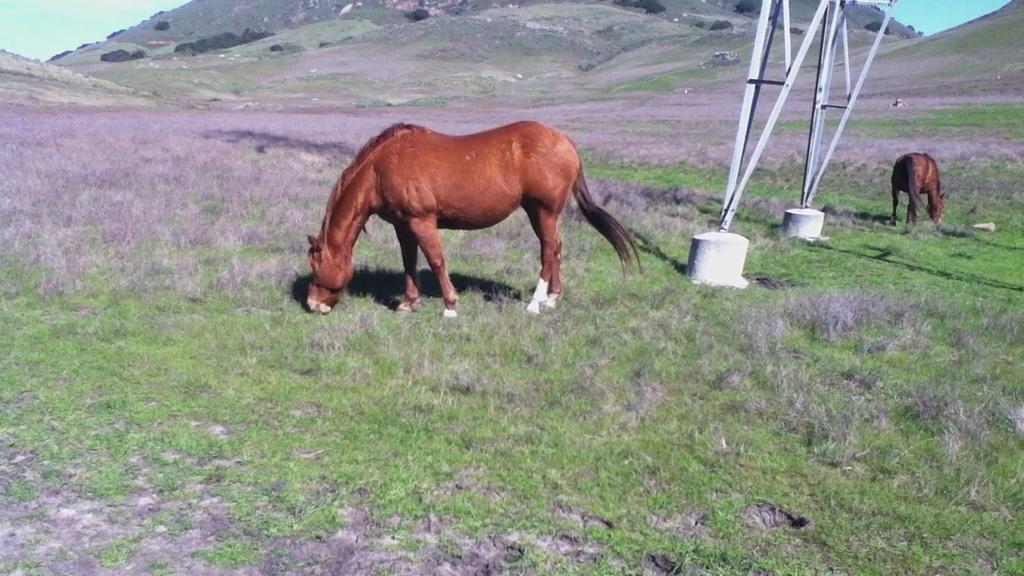In one or two sentences, can you explain what this image depicts? In the foreground of this image, there are two horses and a pole on the grass. In the background, there are slope grounds and the sky. 